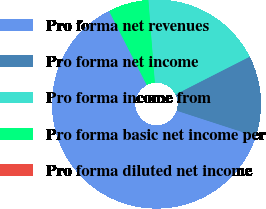Convert chart to OTSL. <chart><loc_0><loc_0><loc_500><loc_500><pie_chart><fcel>Pro forma net revenues<fcel>Pro forma net income<fcel>Pro forma income from<fcel>Pro forma basic net income per<fcel>Pro forma diluted net income<nl><fcel>62.5%<fcel>12.5%<fcel>18.75%<fcel>6.25%<fcel>0.0%<nl></chart> 